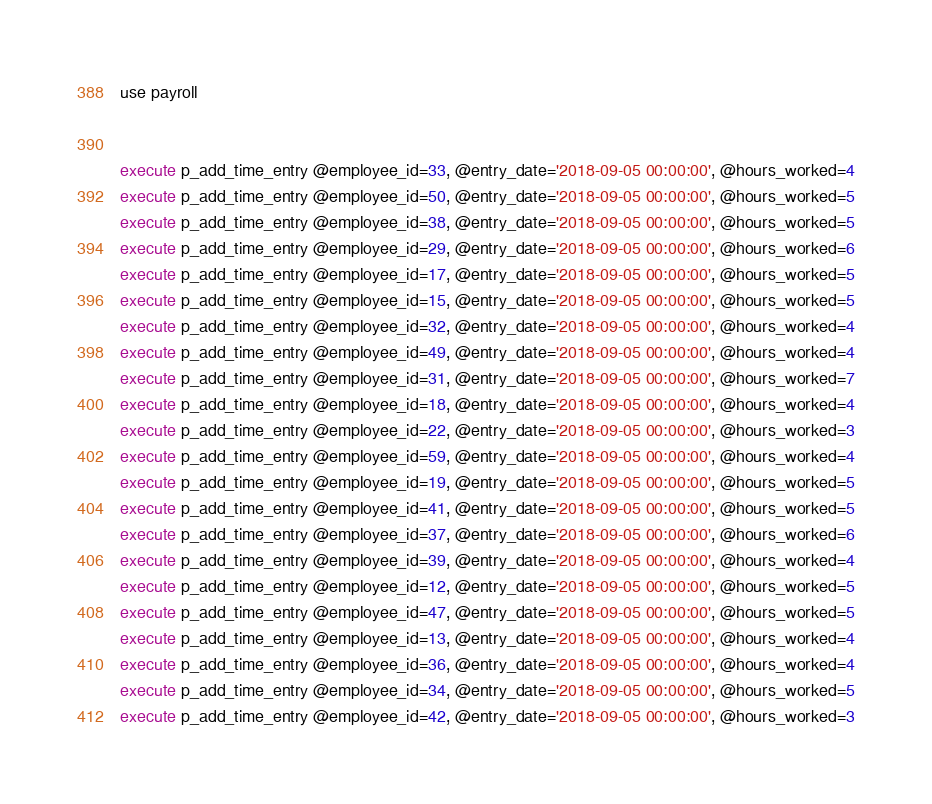Convert code to text. <code><loc_0><loc_0><loc_500><loc_500><_SQL_>use payroll


execute p_add_time_entry @employee_id=33, @entry_date='2018-09-05 00:00:00', @hours_worked=4
execute p_add_time_entry @employee_id=50, @entry_date='2018-09-05 00:00:00', @hours_worked=5
execute p_add_time_entry @employee_id=38, @entry_date='2018-09-05 00:00:00', @hours_worked=5
execute p_add_time_entry @employee_id=29, @entry_date='2018-09-05 00:00:00', @hours_worked=6
execute p_add_time_entry @employee_id=17, @entry_date='2018-09-05 00:00:00', @hours_worked=5
execute p_add_time_entry @employee_id=15, @entry_date='2018-09-05 00:00:00', @hours_worked=5
execute p_add_time_entry @employee_id=32, @entry_date='2018-09-05 00:00:00', @hours_worked=4
execute p_add_time_entry @employee_id=49, @entry_date='2018-09-05 00:00:00', @hours_worked=4
execute p_add_time_entry @employee_id=31, @entry_date='2018-09-05 00:00:00', @hours_worked=7
execute p_add_time_entry @employee_id=18, @entry_date='2018-09-05 00:00:00', @hours_worked=4
execute p_add_time_entry @employee_id=22, @entry_date='2018-09-05 00:00:00', @hours_worked=3
execute p_add_time_entry @employee_id=59, @entry_date='2018-09-05 00:00:00', @hours_worked=4
execute p_add_time_entry @employee_id=19, @entry_date='2018-09-05 00:00:00', @hours_worked=5
execute p_add_time_entry @employee_id=41, @entry_date='2018-09-05 00:00:00', @hours_worked=5
execute p_add_time_entry @employee_id=37, @entry_date='2018-09-05 00:00:00', @hours_worked=6
execute p_add_time_entry @employee_id=39, @entry_date='2018-09-05 00:00:00', @hours_worked=4
execute p_add_time_entry @employee_id=12, @entry_date='2018-09-05 00:00:00', @hours_worked=5
execute p_add_time_entry @employee_id=47, @entry_date='2018-09-05 00:00:00', @hours_worked=5
execute p_add_time_entry @employee_id=13, @entry_date='2018-09-05 00:00:00', @hours_worked=4
execute p_add_time_entry @employee_id=36, @entry_date='2018-09-05 00:00:00', @hours_worked=4
execute p_add_time_entry @employee_id=34, @entry_date='2018-09-05 00:00:00', @hours_worked=5
execute p_add_time_entry @employee_id=42, @entry_date='2018-09-05 00:00:00', @hours_worked=3

</code> 